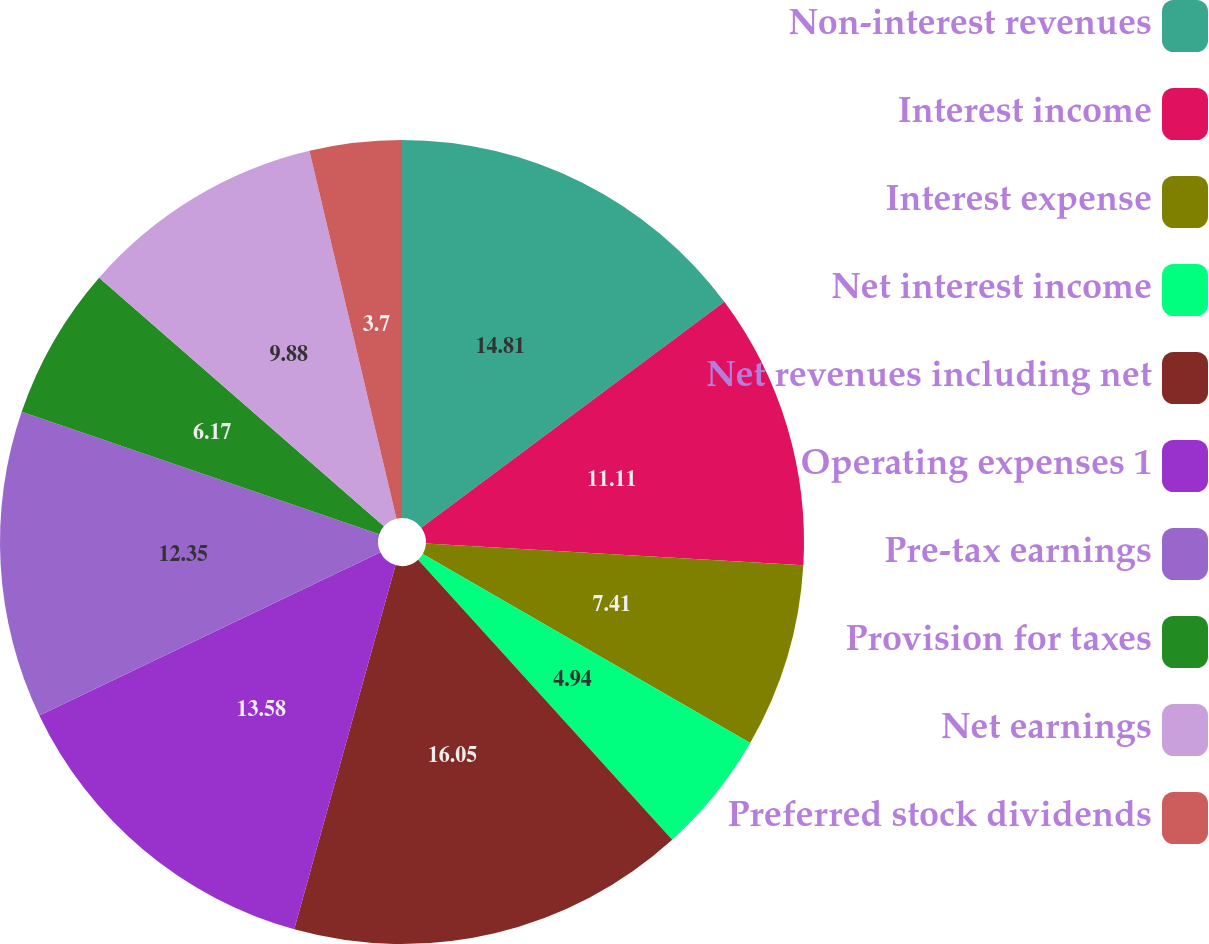Convert chart to OTSL. <chart><loc_0><loc_0><loc_500><loc_500><pie_chart><fcel>Non-interest revenues<fcel>Interest income<fcel>Interest expense<fcel>Net interest income<fcel>Net revenues including net<fcel>Operating expenses 1<fcel>Pre-tax earnings<fcel>Provision for taxes<fcel>Net earnings<fcel>Preferred stock dividends<nl><fcel>14.81%<fcel>11.11%<fcel>7.41%<fcel>4.94%<fcel>16.05%<fcel>13.58%<fcel>12.35%<fcel>6.17%<fcel>9.88%<fcel>3.7%<nl></chart> 